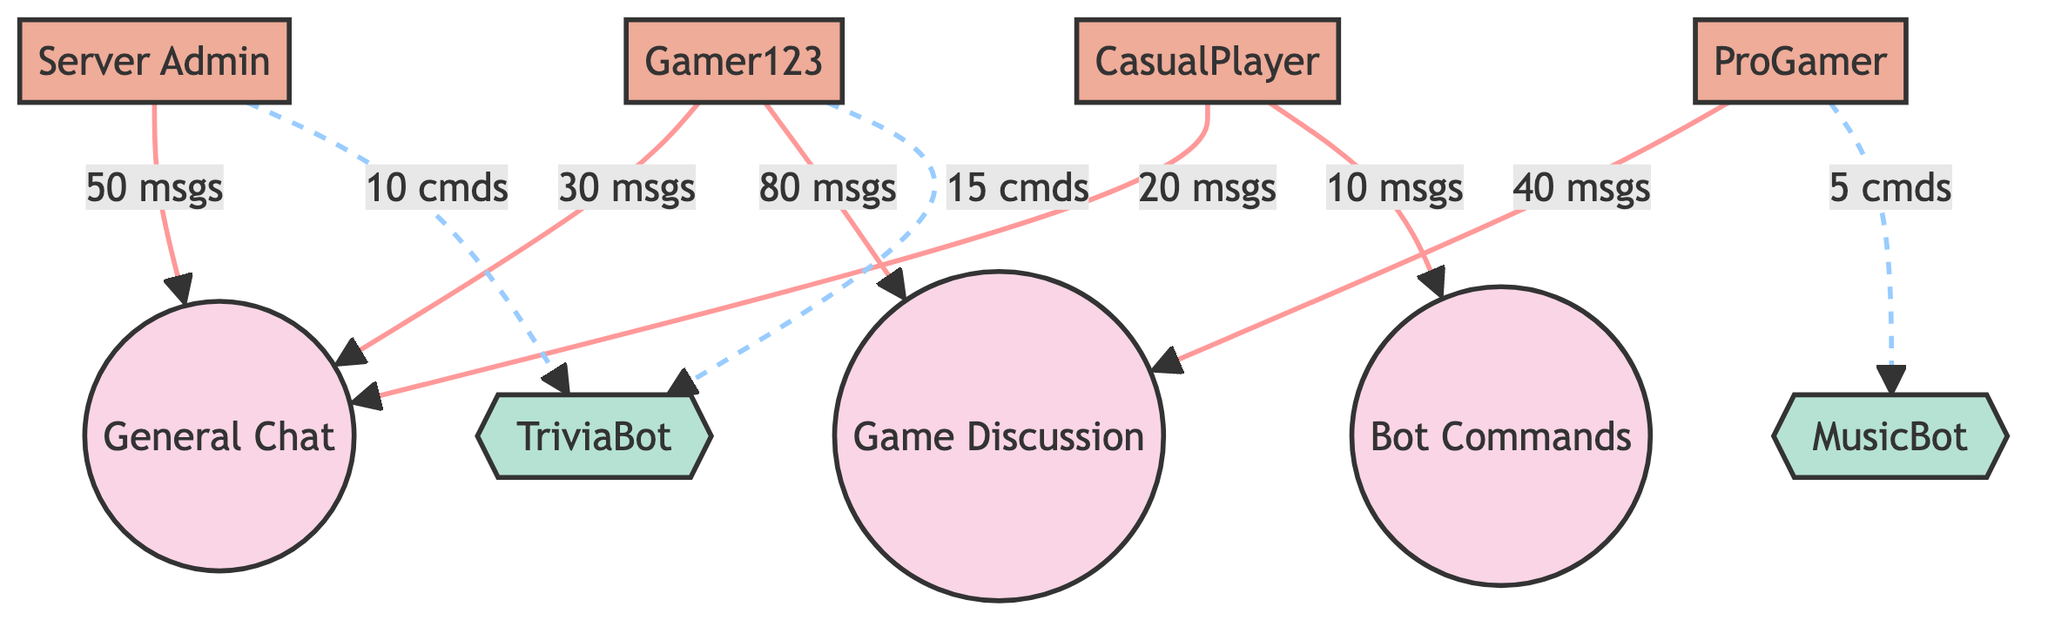What is the total number of nodes in the diagram? The diagram consists of 9 nodes in total, which include chat channels, users, and bots. Counting each distinct node listed, we arrive at 9.
Answer: 9 Which user has the highest message count in General Chat? The user "Server Admin" has sent 50 messages in the General Chat, which is the highest count among the users in that channel.
Answer: Server Admin How many commands were sent to TriviaBot? The total number of commands sent to TriviaBot by both the Server Admin and Gamer123 is 25 (10 from the Server Admin + 15 from Gamer123).
Answer: 25 Which channel received the most messages and how many? The channel "Game Discussion" received the most messages, totaling 120 messages (80 from Gamer123 and 40 from ProGamer).
Answer: Game Discussion, 120 What type of interaction did Gamer123 have with Bot Commands? Gamer123 interacted with the Bot Commands channel using messages, sending a total of 10 messages.
Answer: message How many unique users interacted with the General Chat? Three unique users interacted with the General Chat: Server Admin, Gamer123, and CasualPlayer.
Answer: 3 Which bot received the least commands and what was the count? MusicBot received the least commands with a count of 5 commands from ProGamer.
Answer: MusicBot, 5 What is the relationship type between Server Admin and Game Discussion? The relationship type between Server Admin and Game Discussion is a message, indicating that Server Admin has sent messages to this channel.
Answer: message Which channel had the least number of messages and how many were sent? The Bot Commands channel had the least number of messages, with a total of 10 messages sent by CasualPlayer.
Answer: Bot Commands, 10 